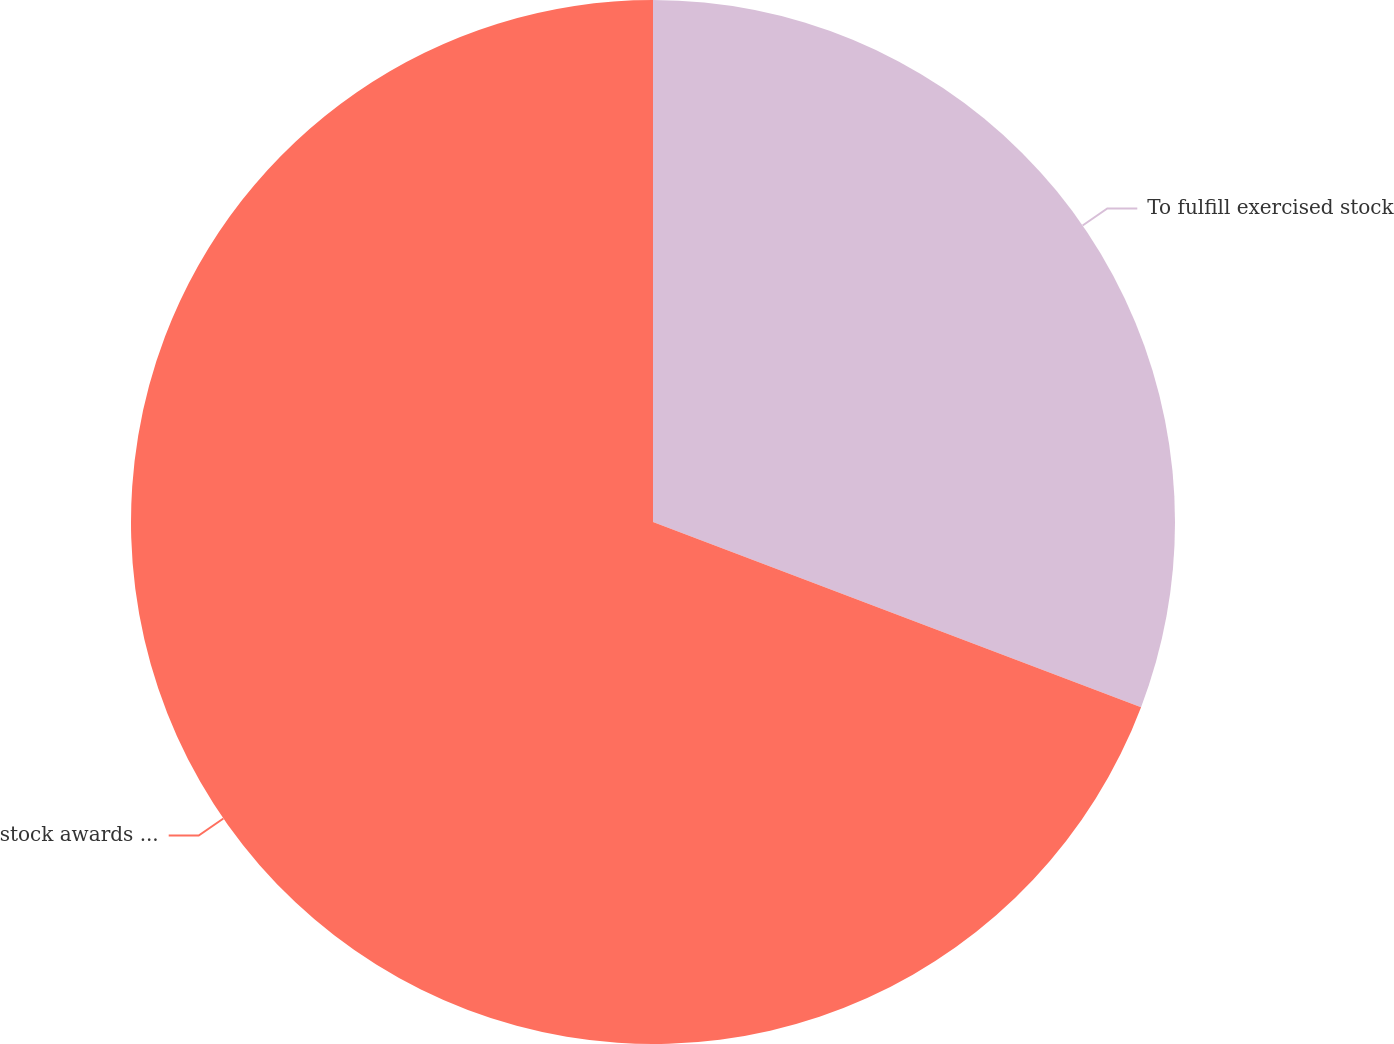Convert chart. <chart><loc_0><loc_0><loc_500><loc_500><pie_chart><fcel>To fulfill exercised stock<fcel>stock awards Total<nl><fcel>30.77%<fcel>69.23%<nl></chart> 